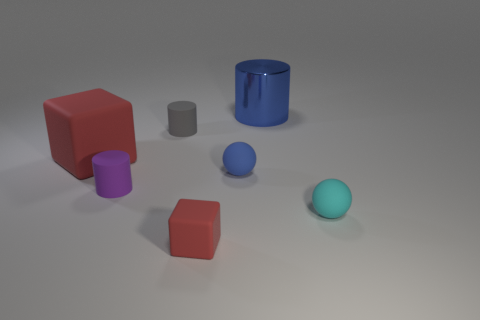How many blue metallic cylinders are the same size as the cyan matte object?
Make the answer very short. 0. There is a object that is the same color as the big shiny cylinder; what is its shape?
Your response must be concise. Sphere. What number of things are matte cylinders that are in front of the tiny blue rubber sphere or tiny brown matte cylinders?
Your response must be concise. 1. Is the number of big blue objects less than the number of big yellow rubber things?
Offer a very short reply. No. What shape is the tiny gray thing that is made of the same material as the cyan object?
Give a very brief answer. Cylinder. Are there any balls behind the cyan matte sphere?
Provide a short and direct response. Yes. Are there fewer cyan spheres that are to the left of the small gray matte thing than large red matte objects?
Make the answer very short. Yes. What is the large blue cylinder made of?
Keep it short and to the point. Metal. The small rubber block is what color?
Provide a short and direct response. Red. What is the color of the small thing that is to the right of the gray cylinder and behind the tiny cyan matte ball?
Your answer should be compact. Blue. 